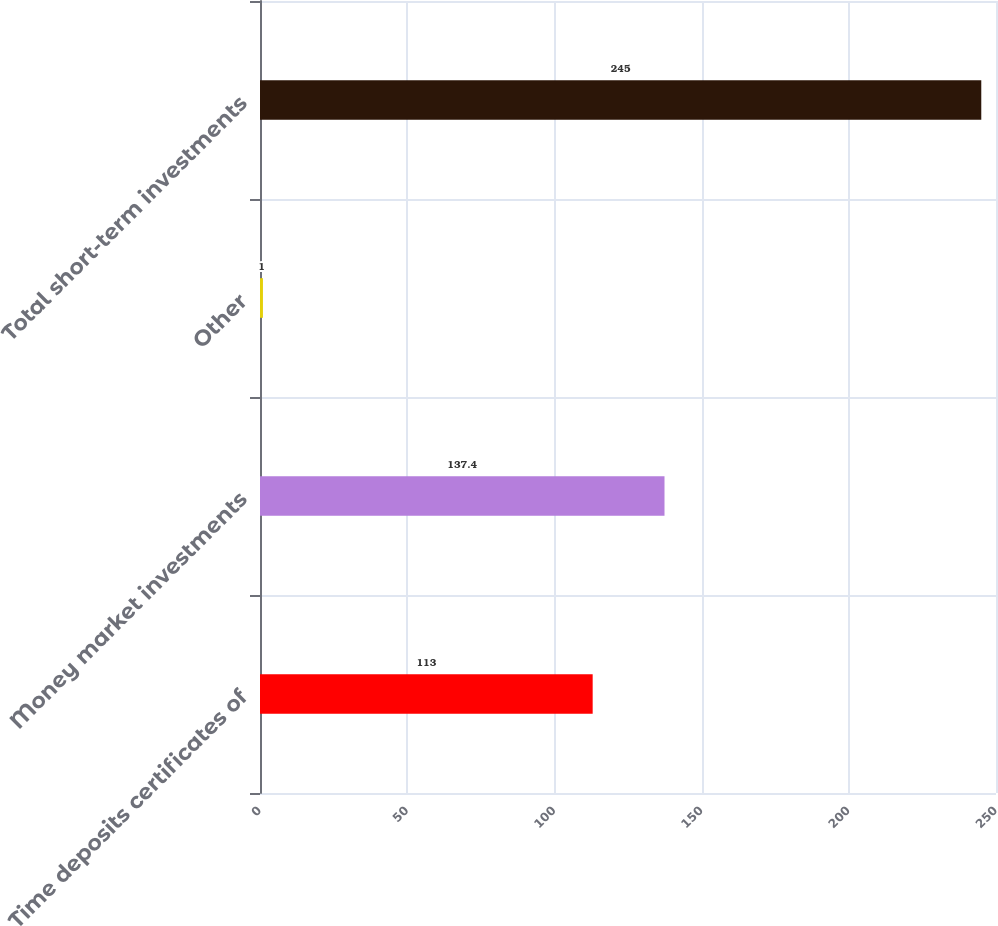<chart> <loc_0><loc_0><loc_500><loc_500><bar_chart><fcel>Time deposits certificates of<fcel>Money market investments<fcel>Other<fcel>Total short-term investments<nl><fcel>113<fcel>137.4<fcel>1<fcel>245<nl></chart> 